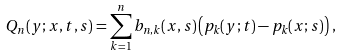<formula> <loc_0><loc_0><loc_500><loc_500>Q _ { n } ( y ; x , t , s ) = \sum _ { k = 1 } ^ { n } b _ { n , k } ( x , s ) \left ( p _ { k } ( y ; t ) - p _ { k } ( x ; s ) \right ) \, ,</formula> 